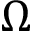Convert formula to latex. <formula><loc_0><loc_0><loc_500><loc_500>\Omega</formula> 